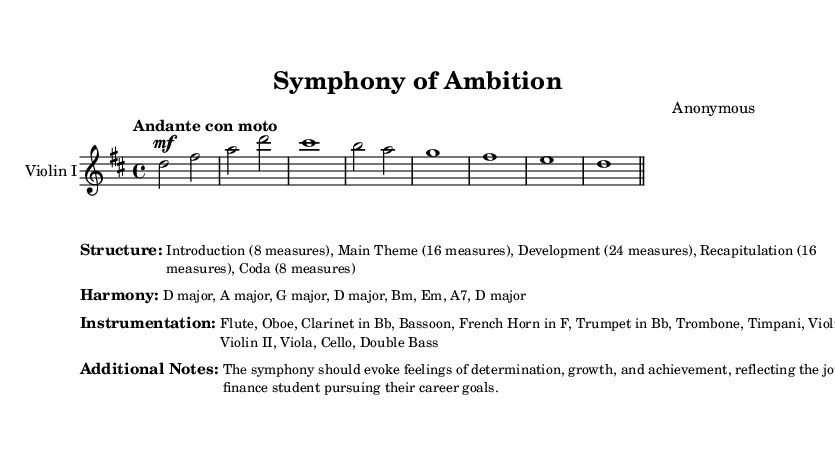What is the key signature of this music? The key signature is D major, which has two sharps (F# and C#). This can be determined by looking at the key indicated at the beginning of the sheet music.
Answer: D major What is the time signature of this music? The time signature is 4/4, indicated at the beginning of the sheet music. This means there are four beats in each measure and a quarter note receives one beat.
Answer: 4/4 What is the tempo marking of this music? The tempo marking is "Andante con moto," which indicates a moderately slow pace with a slight motion. This can be found in the tempo indication provided.
Answer: Andante con moto How many measures are in the Introduction section? The Introduction section consists of 8 measures, as detailed in the structure breakdown provided in the markup section of the music.
Answer: 8 measures How many different instruments are listed in the instrumentation? There are 12 different instruments listed, as specified in the instrumentation markup. The instruments are Flute, Oboe, Clarinet in Bb, Bassoon, French Horn in F, Trumpet in Bb, Trombone, Timpani, Violin I, Violin II, Viola, Cello, and Double Bass.
Answer: 12 instruments What is the emotional theme intended by this symphony? The emotional theme intended by this symphony is to evoke feelings of determination, growth, and achievement, reflecting the journey of a finance student pursuing their career goals. This theme is explicitly mentioned in the Additional Notes section.
Answer: Determination, growth, and achievement 